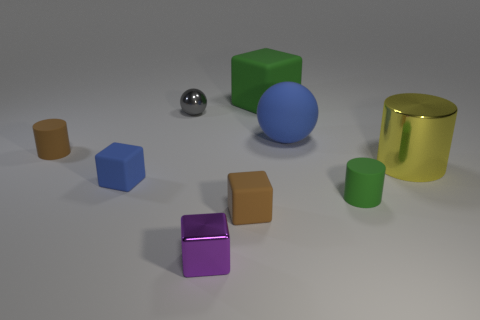Subtract all small purple blocks. How many blocks are left? 3 Subtract all brown cylinders. How many cylinders are left? 2 Subtract 0 yellow cubes. How many objects are left? 9 Subtract all spheres. How many objects are left? 7 Subtract 3 cylinders. How many cylinders are left? 0 Subtract all yellow cubes. Subtract all yellow balls. How many cubes are left? 4 Subtract all brown cubes. How many gray balls are left? 1 Subtract all large objects. Subtract all big green rubber objects. How many objects are left? 5 Add 8 small brown rubber cylinders. How many small brown rubber cylinders are left? 9 Add 9 yellow cylinders. How many yellow cylinders exist? 10 